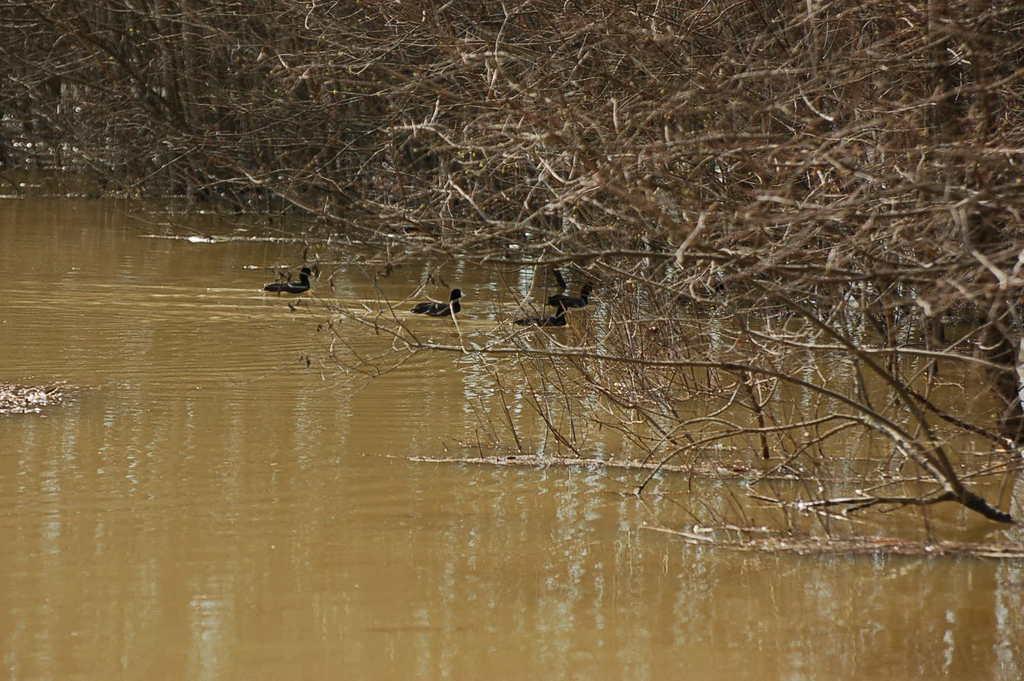Please provide a concise description of this image. In this image we can see ducks in the water. On the right side there are branches of trees. In the back there are trees. 